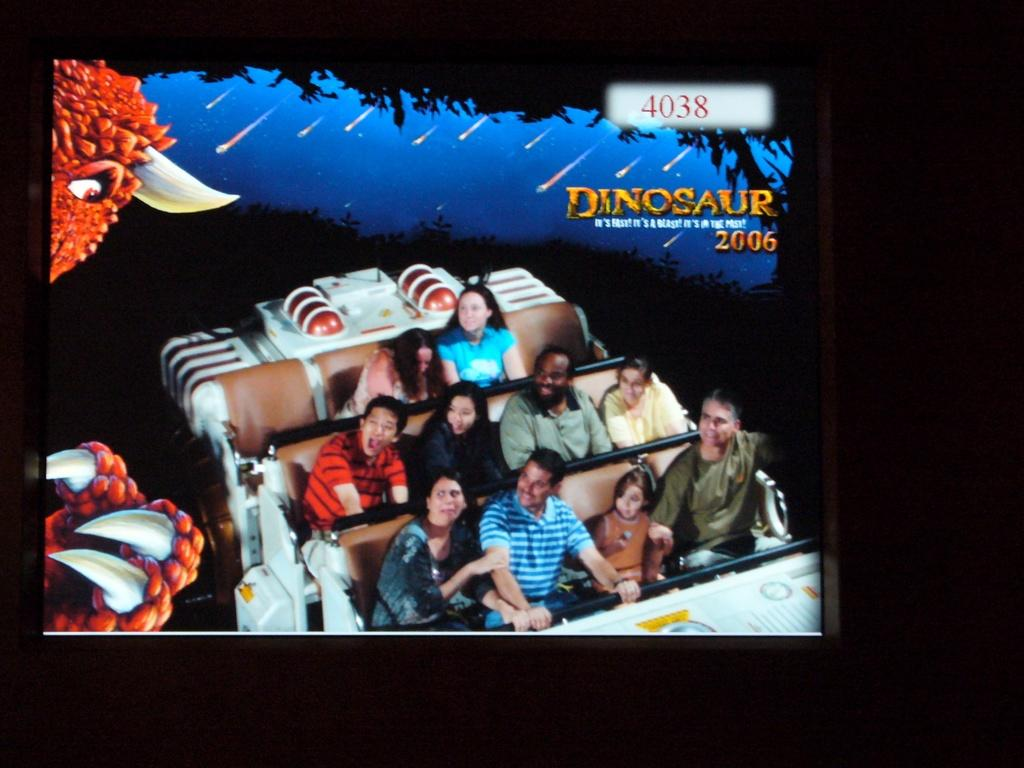What are the people in the image doing? The people in the image are sitting on a roller coaster. Where is the roller coaster located in the image? The roller coaster is in the middle of the image. What can be seen on the upper right side of the image? There is text in the image that says "dinosaur" on the upper right side. What type of shirt is the lamp wearing in the image? There is: There is no lamp or shirt present in the image. 